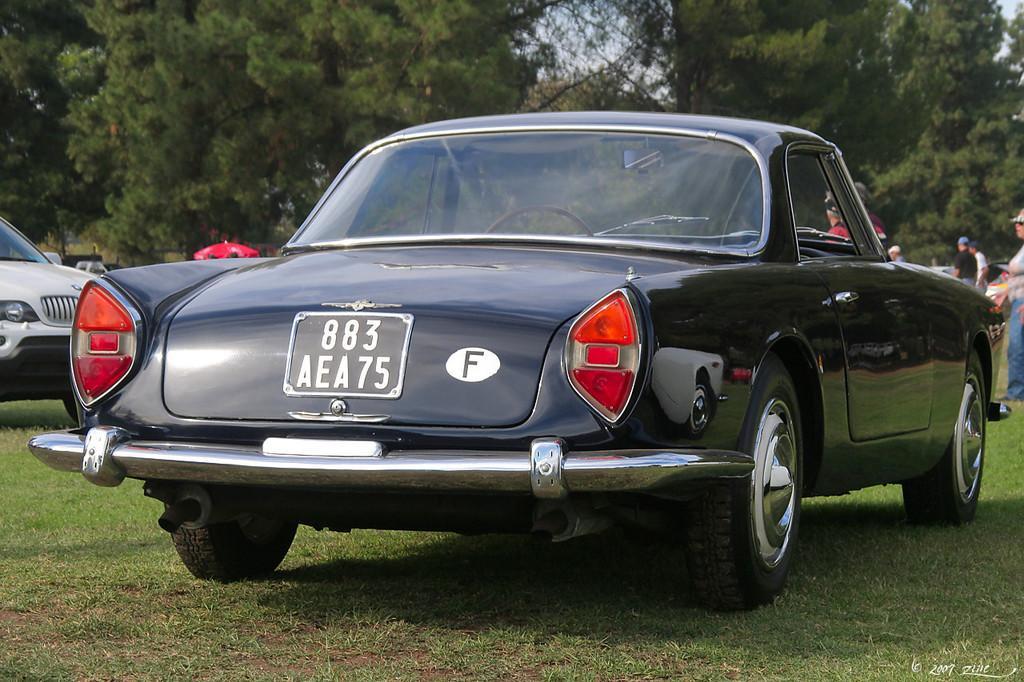Can you describe this image briefly? Here we can see a car on the grass on the ground. In the background there are trees and sky. On the left we can see a vehicle on the ground and on the right there are few persons standing on the ground. 